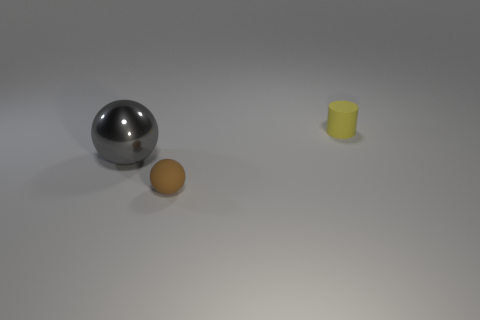Add 2 gray things. How many objects exist? 5 Subtract all cylinders. How many objects are left? 2 Subtract 1 cylinders. How many cylinders are left? 0 Subtract all small rubber cylinders. Subtract all small yellow objects. How many objects are left? 1 Add 2 yellow cylinders. How many yellow cylinders are left? 3 Add 2 large red matte cubes. How many large red matte cubes exist? 2 Subtract 0 cyan blocks. How many objects are left? 3 Subtract all brown cylinders. Subtract all red spheres. How many cylinders are left? 1 